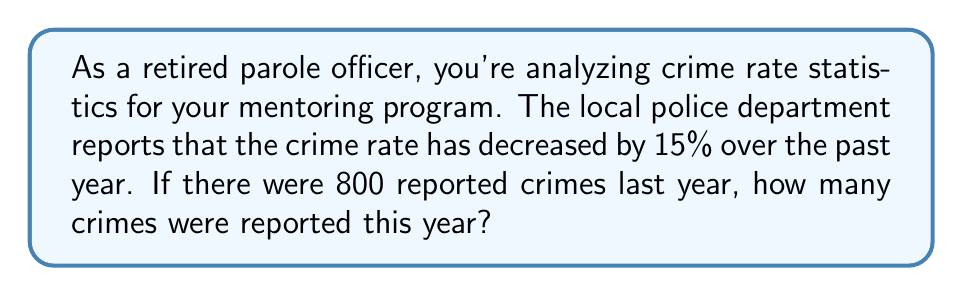Solve this math problem. Let's approach this step-by-step:

1) First, we need to understand what a 15% decrease means. It means that the new number of crimes is 85% of the original number.

2) We can express this mathematically as:
   $$ \text{New number of crimes} = \text{Original number of crimes} \times (1 - 0.15) $$
   $$ \text{New number of crimes} = \text{Original number of crimes} \times 0.85 $$

3) We know that the original number of crimes was 800. Let's plug this into our equation:
   $$ \text{New number of crimes} = 800 \times 0.85 $$

4) Now, let's calculate:
   $$ \text{New number of crimes} = 680 $$

5) To verify, we can check if this indeed represents a 15% decrease:
   $$ \text{Percentage decrease} = \frac{\text{Decrease}}{\text{Original}} \times 100\% $$
   $$ = \frac{800 - 680}{800} \times 100\% = \frac{120}{800} \times 100\% = 15\% $$

This confirms our calculation is correct.
Answer: 680 crimes 